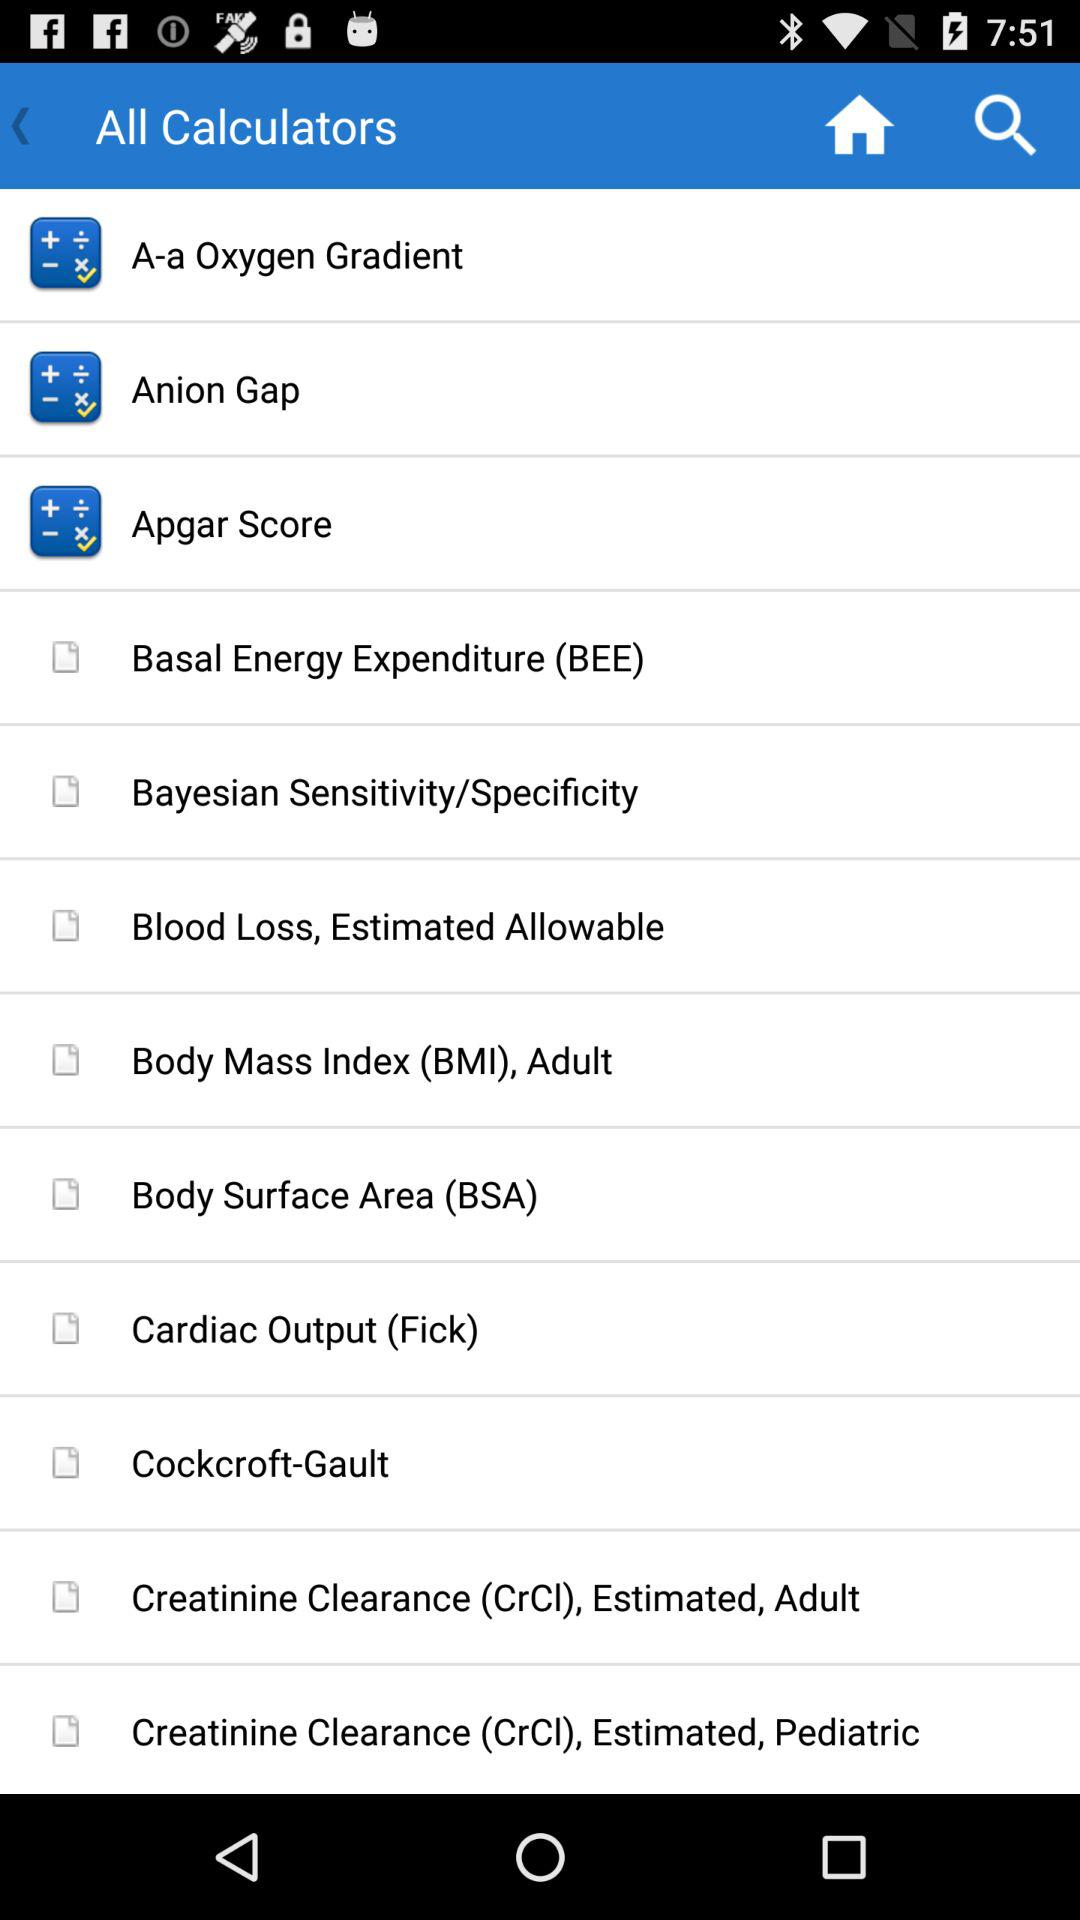What is the full form of BEE? The full form of BEE is Basal Energy Expenditure. 